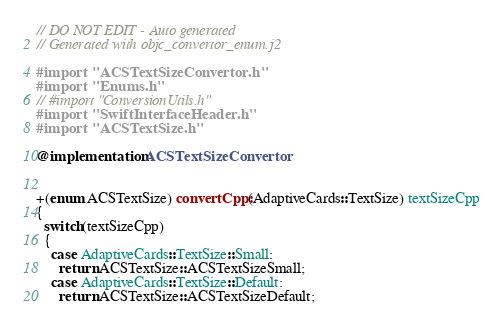Convert code to text. <code><loc_0><loc_0><loc_500><loc_500><_ObjectiveC_>// DO NOT EDIT - Auto generated
// Generated with objc_convertor_enum.j2

#import "ACSTextSizeConvertor.h"
#import "Enums.h"
// #import "ConversionUtils.h"
#import "SwiftInterfaceHeader.h"
#import "ACSTextSize.h"

@implementation ACSTextSizeConvertor


+(enum ACSTextSize) convertCpp:(AdaptiveCards::TextSize) textSizeCpp
{
  switch(textSizeCpp)
  {
    case AdaptiveCards::TextSize::Small:
      return ACSTextSize::ACSTextSizeSmall;
    case AdaptiveCards::TextSize::Default:
      return ACSTextSize::ACSTextSizeDefault;</code> 